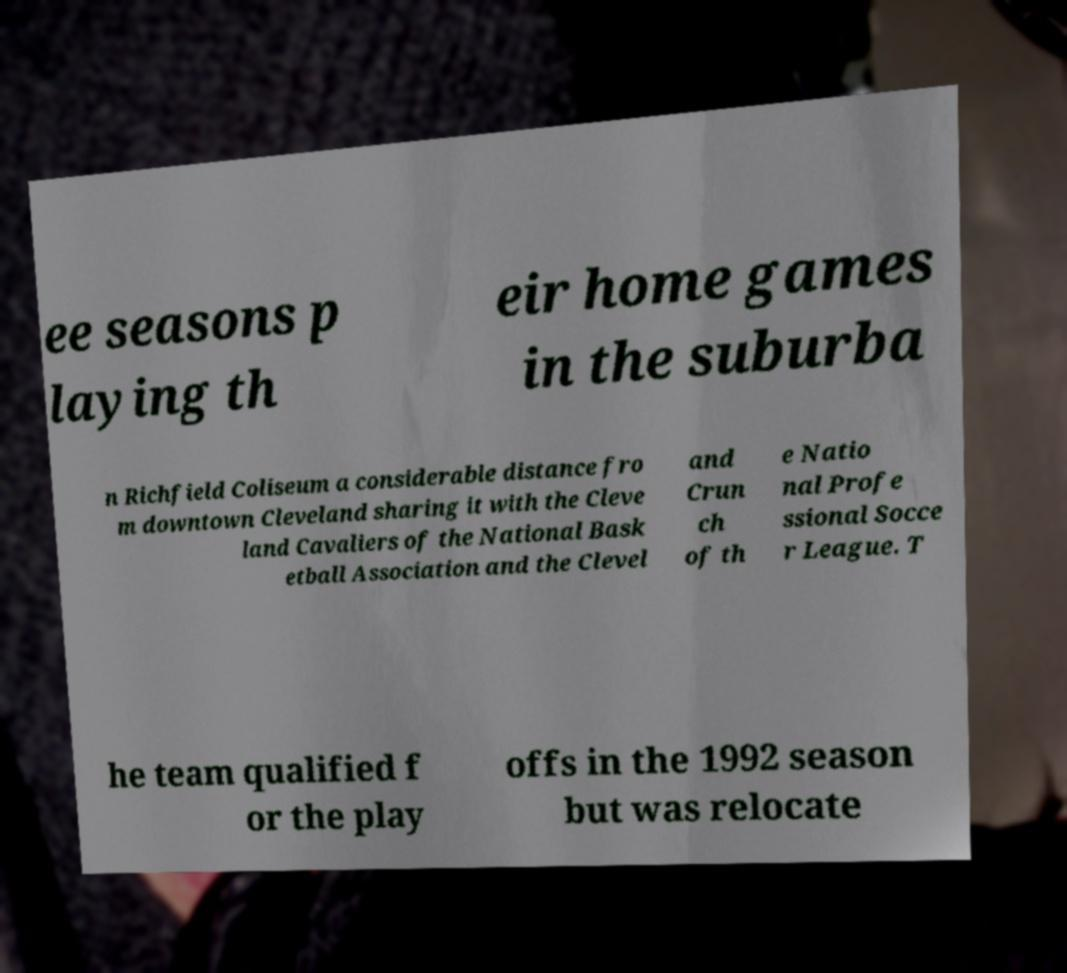I need the written content from this picture converted into text. Can you do that? ee seasons p laying th eir home games in the suburba n Richfield Coliseum a considerable distance fro m downtown Cleveland sharing it with the Cleve land Cavaliers of the National Bask etball Association and the Clevel and Crun ch of th e Natio nal Profe ssional Socce r League. T he team qualified f or the play offs in the 1992 season but was relocate 